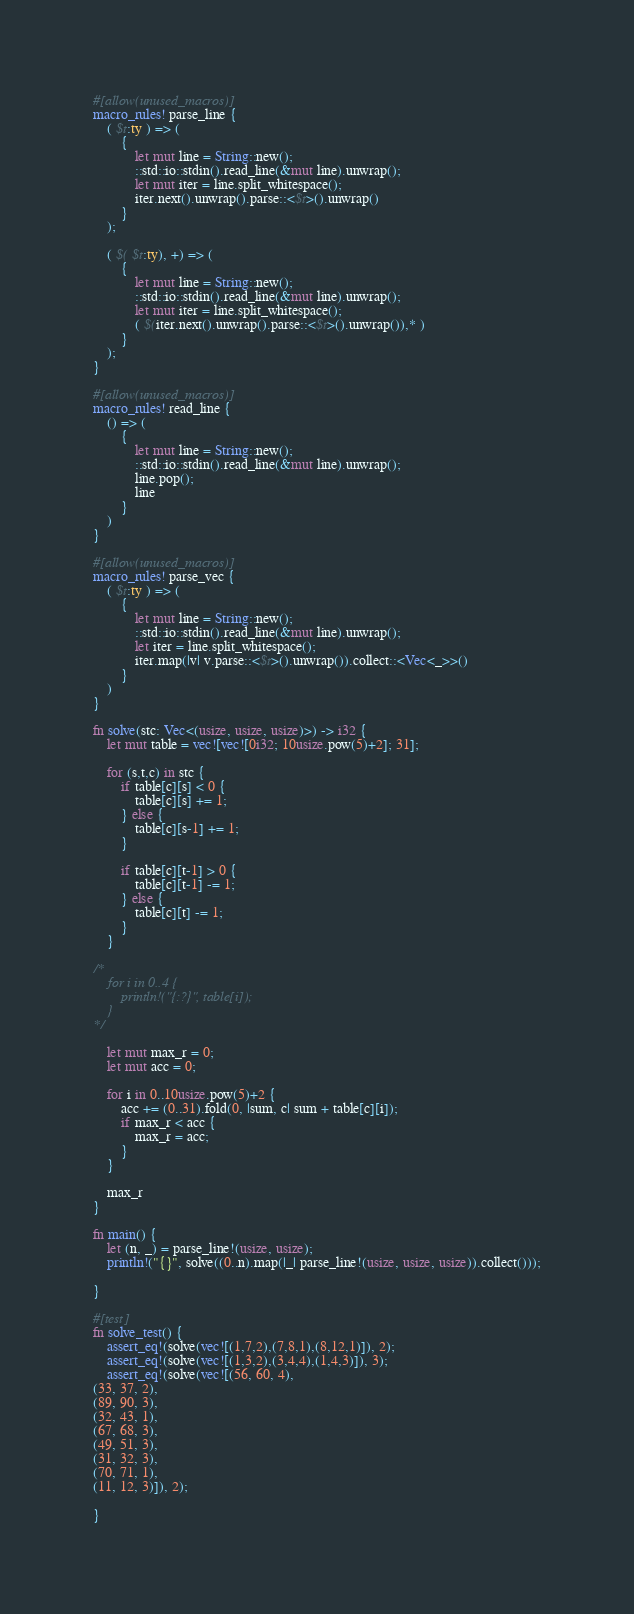<code> <loc_0><loc_0><loc_500><loc_500><_Rust_>#[allow(unused_macros)]
macro_rules! parse_line {
    ( $t:ty ) => (
        {
            let mut line = String::new();
            ::std::io::stdin().read_line(&mut line).unwrap();
            let mut iter = line.split_whitespace();
            iter.next().unwrap().parse::<$t>().unwrap()
        }
    );

    ( $( $t:ty), +) => (
        {
            let mut line = String::new();
            ::std::io::stdin().read_line(&mut line).unwrap();
            let mut iter = line.split_whitespace();
            ( $(iter.next().unwrap().parse::<$t>().unwrap()),* )
        }
    );
}

#[allow(unused_macros)]
macro_rules! read_line {
    () => (
        {
            let mut line = String::new();
            ::std::io::stdin().read_line(&mut line).unwrap();
            line.pop();
            line
        }
    )
}

#[allow(unused_macros)]
macro_rules! parse_vec {
    ( $t:ty ) => (
        {
            let mut line = String::new();
            ::std::io::stdin().read_line(&mut line).unwrap();
            let iter = line.split_whitespace();
            iter.map(|v| v.parse::<$t>().unwrap()).collect::<Vec<_>>()
        }
    )
}

fn solve(stc: Vec<(usize, usize, usize)>) -> i32 {
    let mut table = vec![vec![0i32; 10usize.pow(5)+2]; 31];

    for (s,t,c) in stc {
        if table[c][s] < 0 {
            table[c][s] += 1;
        } else {
            table[c][s-1] += 1;
        }

        if table[c][t-1] > 0 {
            table[c][t-1] -= 1;
        } else {
            table[c][t] -= 1;
        }
    }

/*
    for i in 0..4 {
        println!("{:?}", table[i]);
    }
*/

    let mut max_r = 0;
    let mut acc = 0;

    for i in 0..10usize.pow(5)+2 {
        acc += (0..31).fold(0, |sum, c| sum + table[c][i]);
        if max_r < acc {
            max_r = acc;
        }
    }

    max_r
}

fn main() {
    let (n, _) = parse_line!(usize, usize);
    println!("{}", solve((0..n).map(|_| parse_line!(usize, usize, usize)).collect()));

}

#[test]
fn solve_test() {
    assert_eq!(solve(vec![(1,7,2),(7,8,1),(8,12,1)]), 2);
    assert_eq!(solve(vec![(1,3,2),(3,4,4),(1,4,3)]), 3);
    assert_eq!(solve(vec![(56, 60, 4),
(33, 37, 2),
(89, 90, 3),
(32, 43, 1),
(67, 68, 3),
(49, 51, 3),
(31, 32, 3),
(70, 71, 1),
(11, 12, 3)]), 2);

}
</code> 